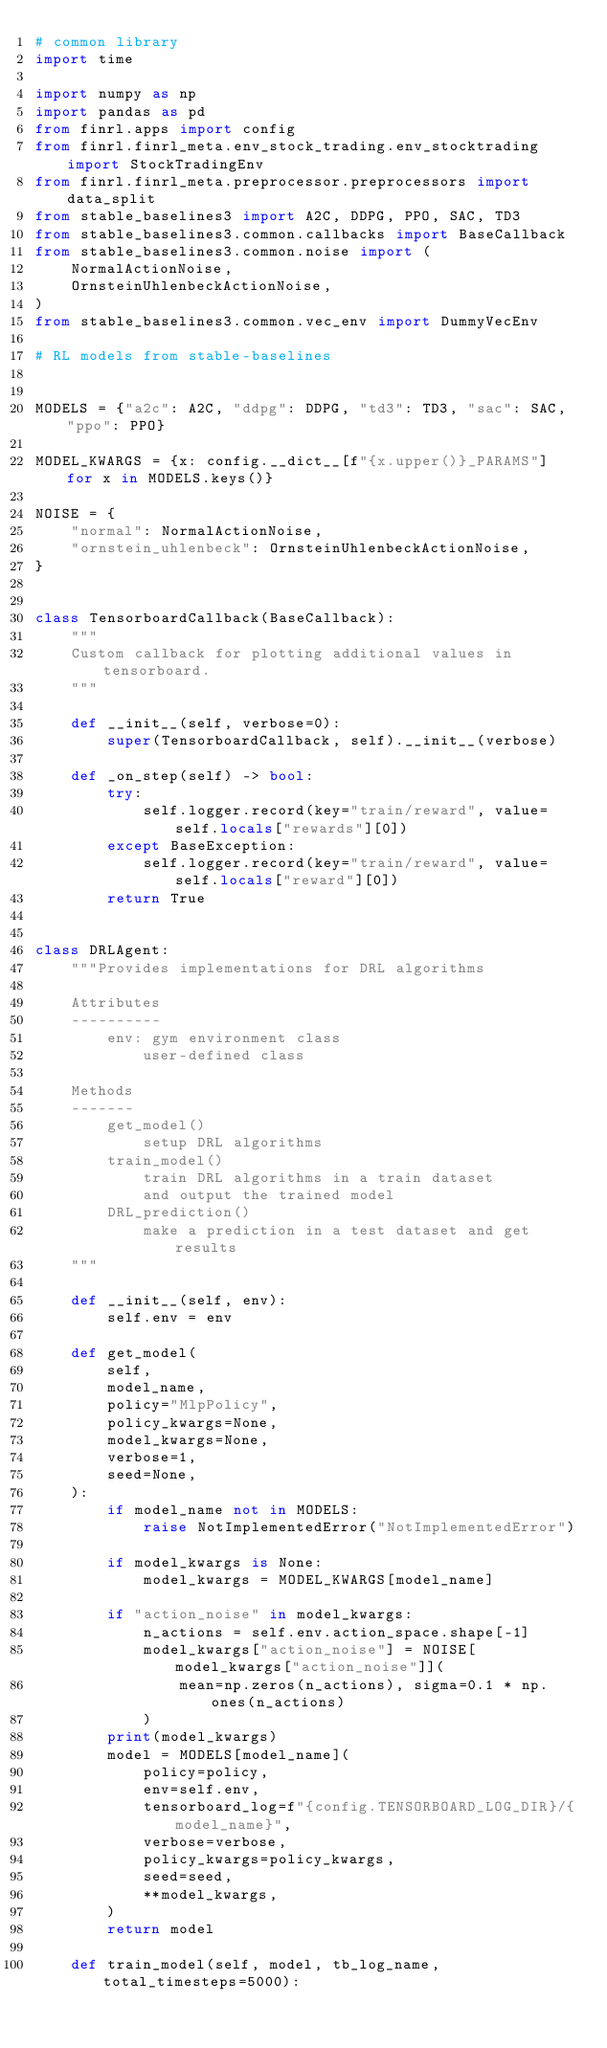<code> <loc_0><loc_0><loc_500><loc_500><_Python_># common library
import time

import numpy as np
import pandas as pd
from finrl.apps import config
from finrl.finrl_meta.env_stock_trading.env_stocktrading import StockTradingEnv
from finrl.finrl_meta.preprocessor.preprocessors import data_split
from stable_baselines3 import A2C, DDPG, PPO, SAC, TD3
from stable_baselines3.common.callbacks import BaseCallback
from stable_baselines3.common.noise import (
    NormalActionNoise,
    OrnsteinUhlenbeckActionNoise,
)
from stable_baselines3.common.vec_env import DummyVecEnv

# RL models from stable-baselines


MODELS = {"a2c": A2C, "ddpg": DDPG, "td3": TD3, "sac": SAC, "ppo": PPO}

MODEL_KWARGS = {x: config.__dict__[f"{x.upper()}_PARAMS"] for x in MODELS.keys()}

NOISE = {
    "normal": NormalActionNoise,
    "ornstein_uhlenbeck": OrnsteinUhlenbeckActionNoise,
}


class TensorboardCallback(BaseCallback):
    """
    Custom callback for plotting additional values in tensorboard.
    """

    def __init__(self, verbose=0):
        super(TensorboardCallback, self).__init__(verbose)

    def _on_step(self) -> bool:
        try:
            self.logger.record(key="train/reward", value=self.locals["rewards"][0])
        except BaseException:
            self.logger.record(key="train/reward", value=self.locals["reward"][0])
        return True


class DRLAgent:
    """Provides implementations for DRL algorithms

    Attributes
    ----------
        env: gym environment class
            user-defined class

    Methods
    -------
        get_model()
            setup DRL algorithms
        train_model()
            train DRL algorithms in a train dataset
            and output the trained model
        DRL_prediction()
            make a prediction in a test dataset and get results
    """

    def __init__(self, env):
        self.env = env

    def get_model(
        self,
        model_name,
        policy="MlpPolicy",
        policy_kwargs=None,
        model_kwargs=None,
        verbose=1,
        seed=None,
    ):
        if model_name not in MODELS:
            raise NotImplementedError("NotImplementedError")

        if model_kwargs is None:
            model_kwargs = MODEL_KWARGS[model_name]

        if "action_noise" in model_kwargs:
            n_actions = self.env.action_space.shape[-1]
            model_kwargs["action_noise"] = NOISE[model_kwargs["action_noise"]](
                mean=np.zeros(n_actions), sigma=0.1 * np.ones(n_actions)
            )
        print(model_kwargs)
        model = MODELS[model_name](
            policy=policy,
            env=self.env,
            tensorboard_log=f"{config.TENSORBOARD_LOG_DIR}/{model_name}",
            verbose=verbose,
            policy_kwargs=policy_kwargs,
            seed=seed,
            **model_kwargs,
        )
        return model

    def train_model(self, model, tb_log_name, total_timesteps=5000):</code> 